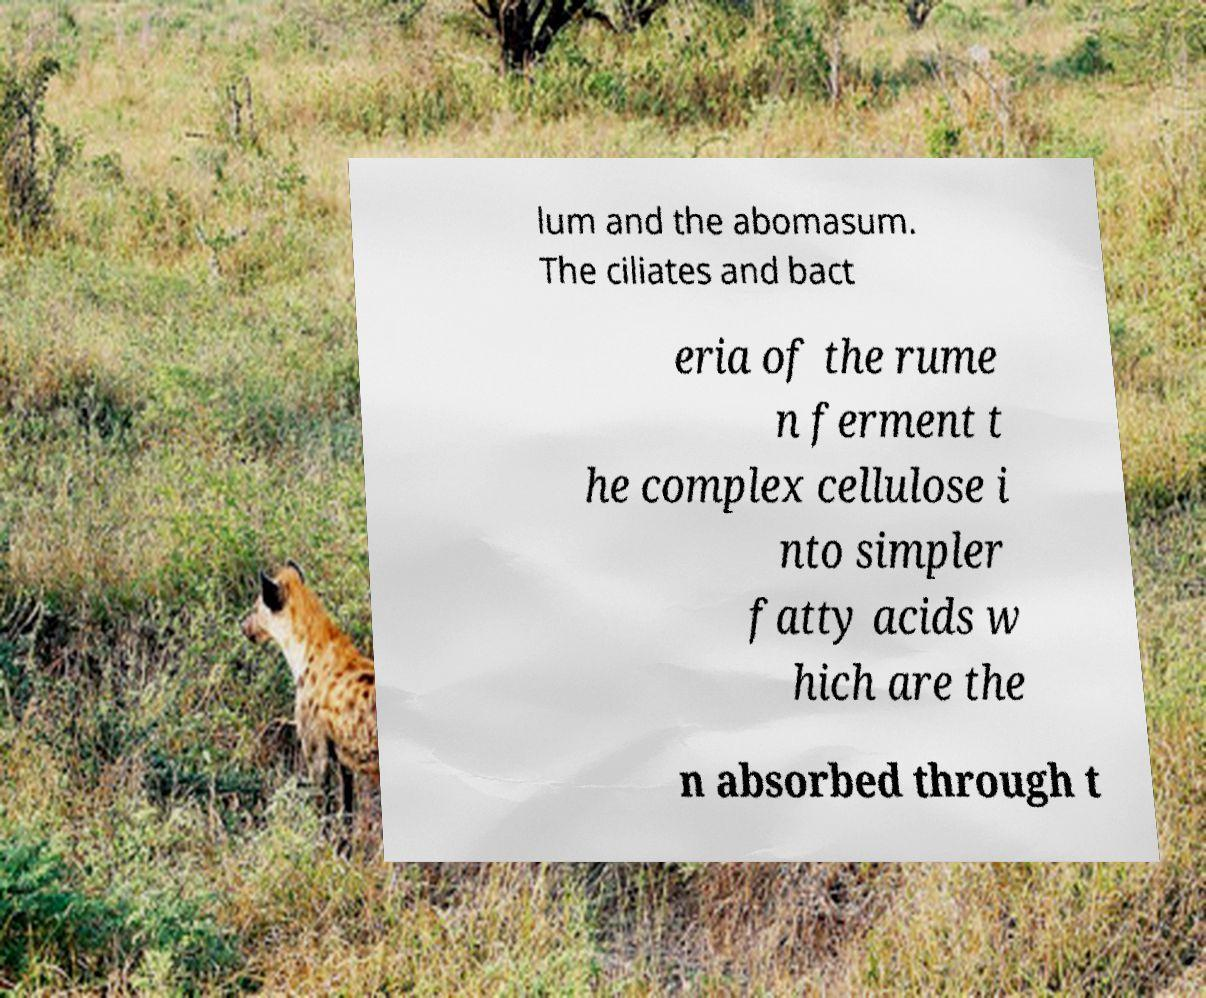Can you accurately transcribe the text from the provided image for me? lum and the abomasum. The ciliates and bact eria of the rume n ferment t he complex cellulose i nto simpler fatty acids w hich are the n absorbed through t 